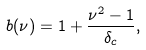Convert formula to latex. <formula><loc_0><loc_0><loc_500><loc_500>b ( \nu ) = 1 + \frac { \nu ^ { 2 } - 1 } { \delta _ { c } } ,</formula> 